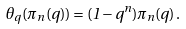Convert formula to latex. <formula><loc_0><loc_0><loc_500><loc_500>\theta _ { q } ( \pi _ { n } ( q ) ) = ( 1 - q ^ { n } ) \pi _ { n } ( q ) \, .</formula> 